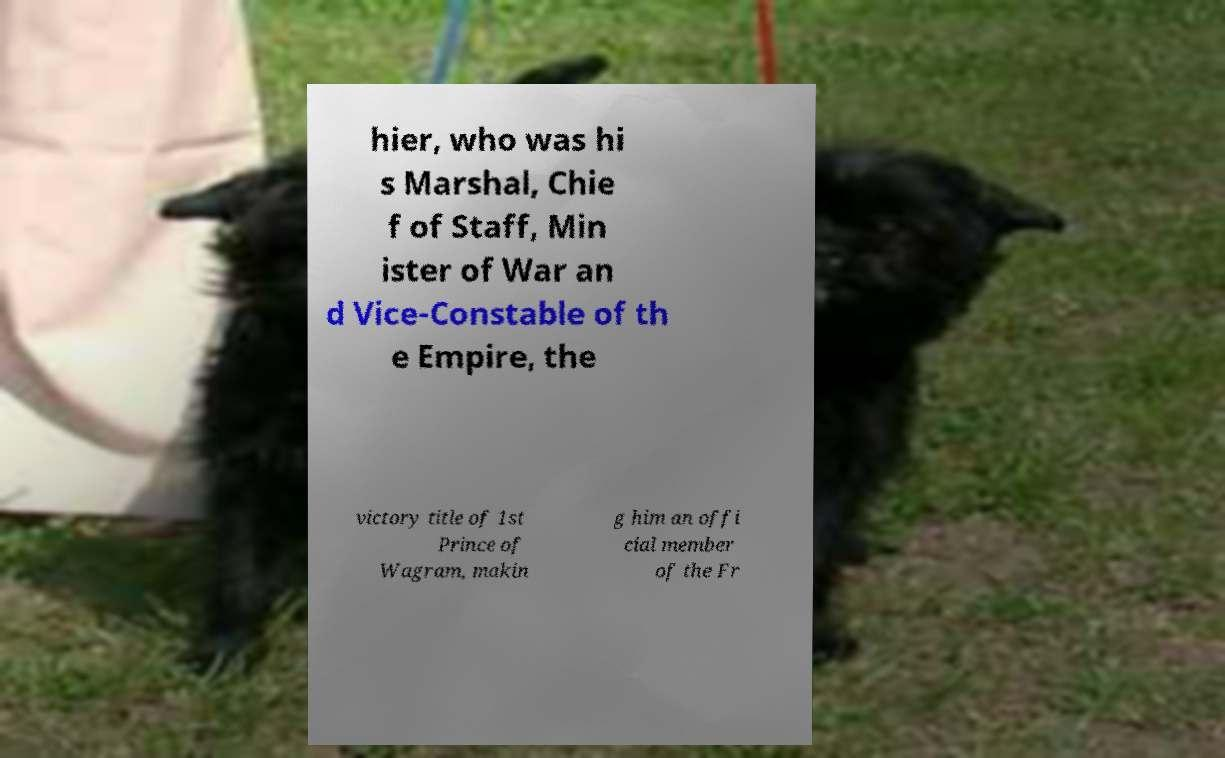I need the written content from this picture converted into text. Can you do that? hier, who was hi s Marshal, Chie f of Staff, Min ister of War an d Vice-Constable of th e Empire, the victory title of 1st Prince of Wagram, makin g him an offi cial member of the Fr 